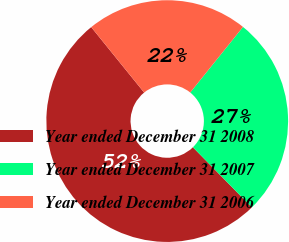<chart> <loc_0><loc_0><loc_500><loc_500><pie_chart><fcel>Year ended December 31 2008<fcel>Year ended December 31 2007<fcel>Year ended December 31 2006<nl><fcel>51.52%<fcel>26.87%<fcel>21.61%<nl></chart> 